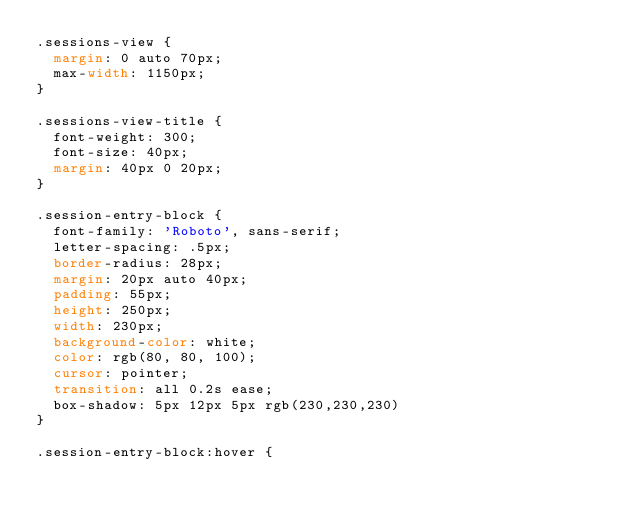<code> <loc_0><loc_0><loc_500><loc_500><_CSS_>.sessions-view {
  margin: 0 auto 70px;
  max-width: 1150px;
}

.sessions-view-title {
  font-weight: 300;
  font-size: 40px;
  margin: 40px 0 20px;
}

.session-entry-block {
  font-family: 'Roboto', sans-serif;
  letter-spacing: .5px;
  border-radius: 28px;
  margin: 20px auto 40px;
  padding: 55px;
  height: 250px;
  width: 230px;
  background-color: white;
  color: rgb(80, 80, 100);
  cursor: pointer;
  transition: all 0.2s ease;
  box-shadow: 5px 12px 5px rgb(230,230,230)
}

.session-entry-block:hover {</code> 